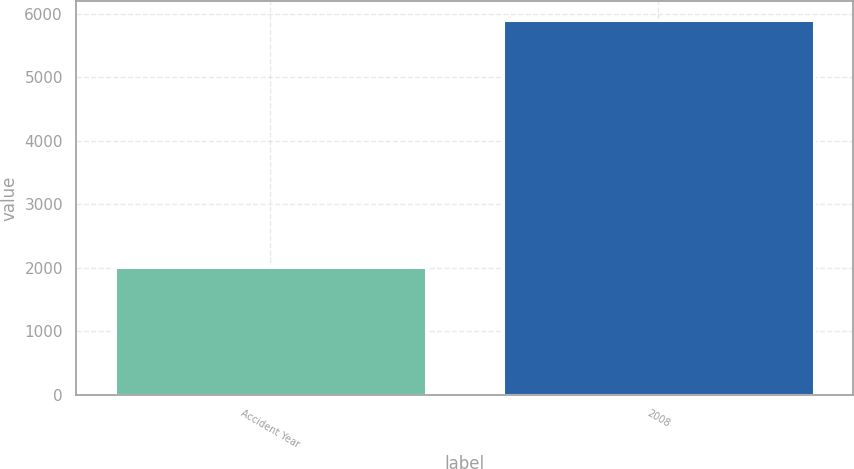Convert chart. <chart><loc_0><loc_0><loc_500><loc_500><bar_chart><fcel>Accident Year<fcel>2008<nl><fcel>2010<fcel>5909<nl></chart> 